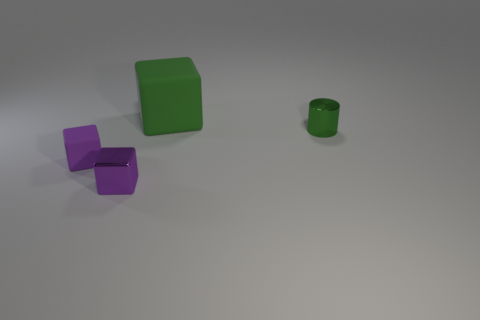Can you tell if the lighting is artificial or natural in the scene? The shadows cast by the objects and the overall lighting in the image suggest that it is an artificial setup, likely illuminated by one or more light sources positioned to create the sense of depth and dimension on the objects.  Is there any indication of movement or stillness in the image? The image captures a still life scene with no apparent motion. The objects are stationary with crisp shadows that indicate a lack of movement and a controlled environment. 